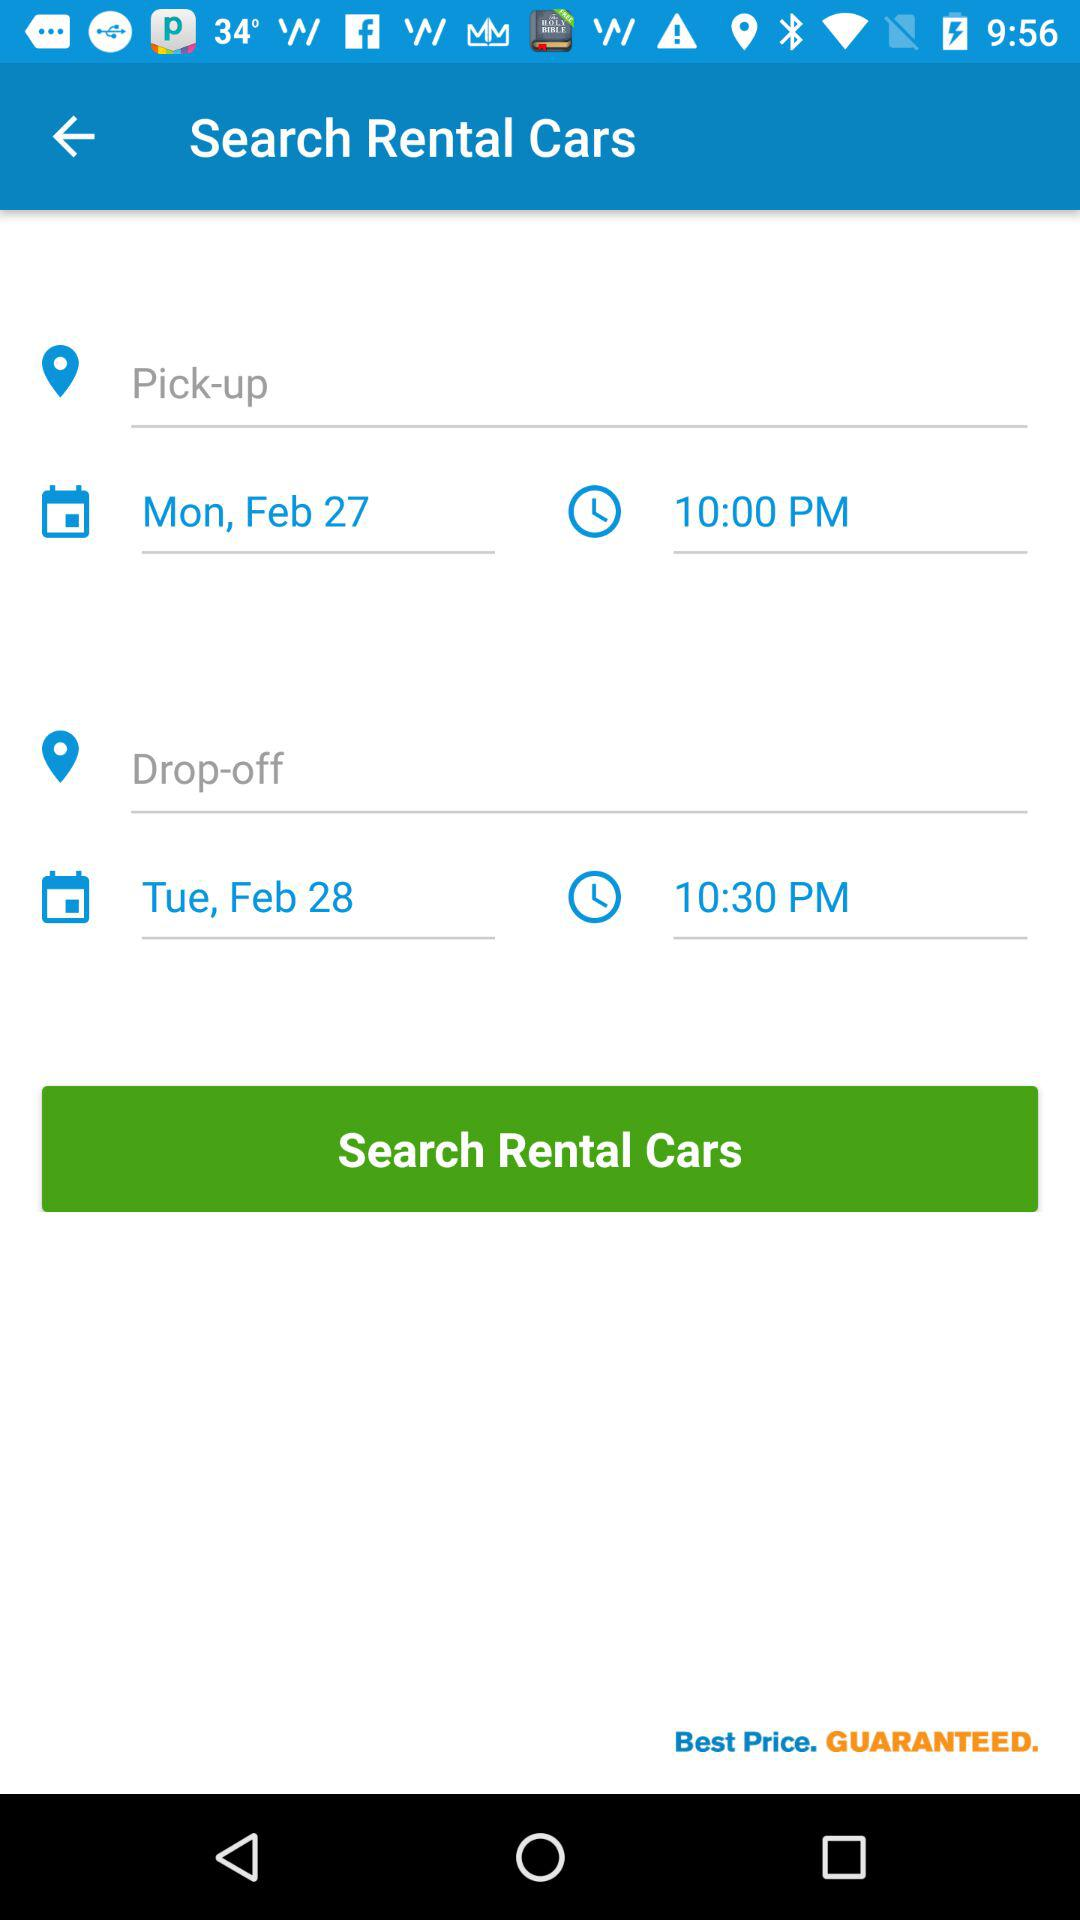How many days are between the pick-up and drop-off dates?
Answer the question using a single word or phrase. 1 